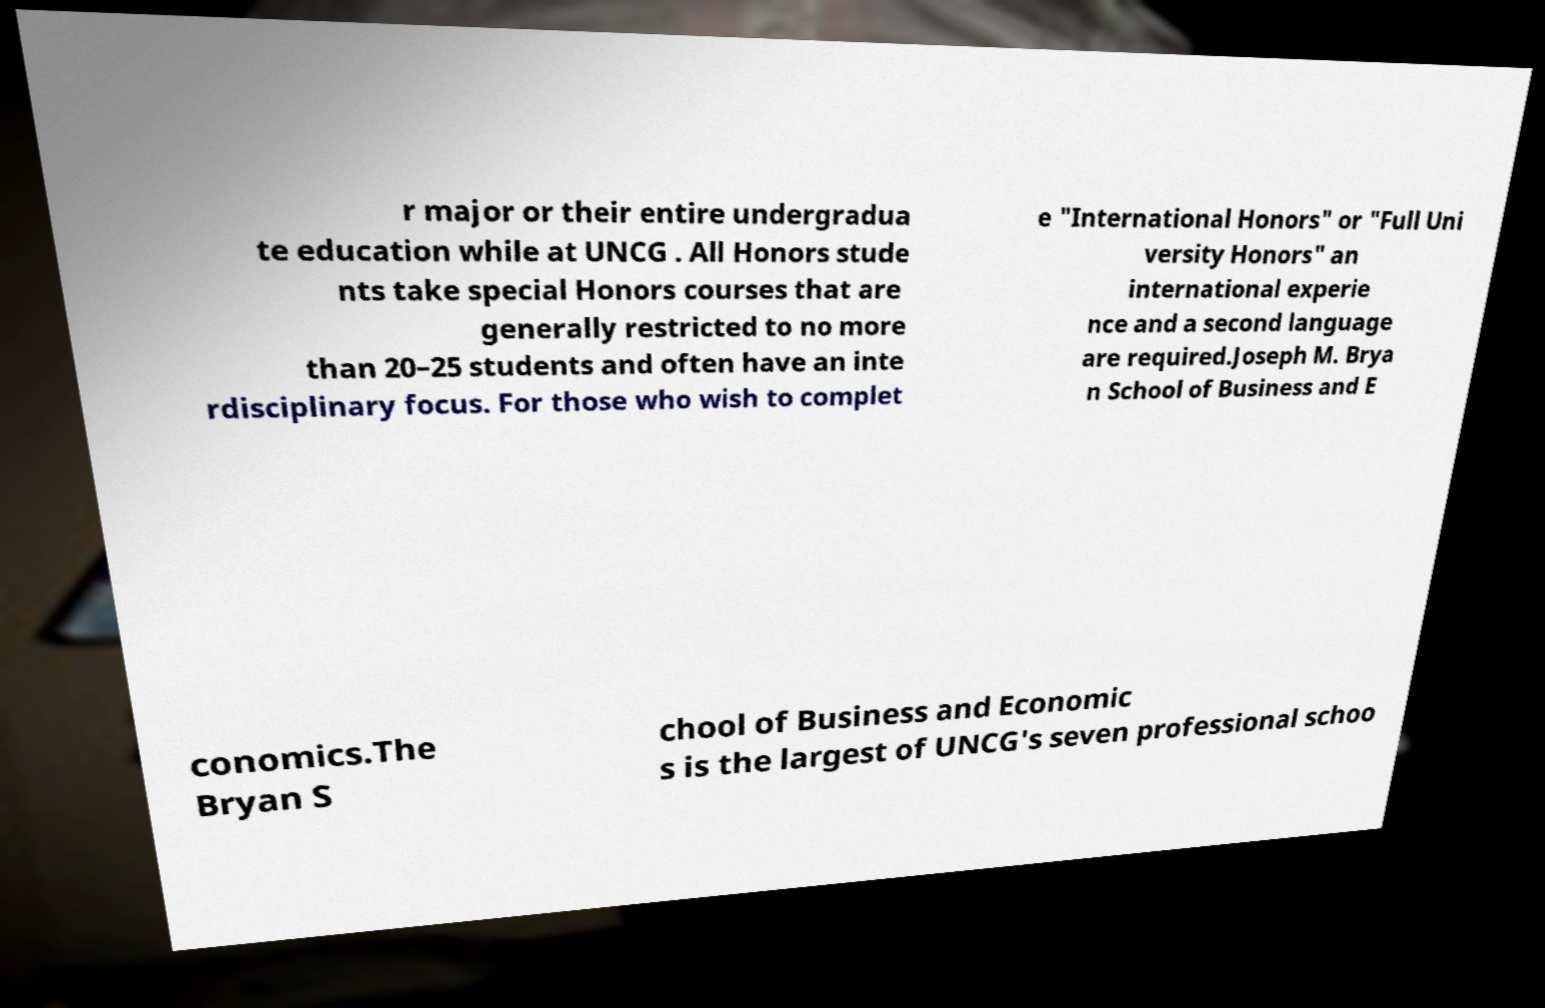Can you read and provide the text displayed in the image?This photo seems to have some interesting text. Can you extract and type it out for me? r major or their entire undergradua te education while at UNCG . All Honors stude nts take special Honors courses that are generally restricted to no more than 20–25 students and often have an inte rdisciplinary focus. For those who wish to complet e "International Honors" or "Full Uni versity Honors" an international experie nce and a second language are required.Joseph M. Brya n School of Business and E conomics.The Bryan S chool of Business and Economic s is the largest of UNCG's seven professional schoo 